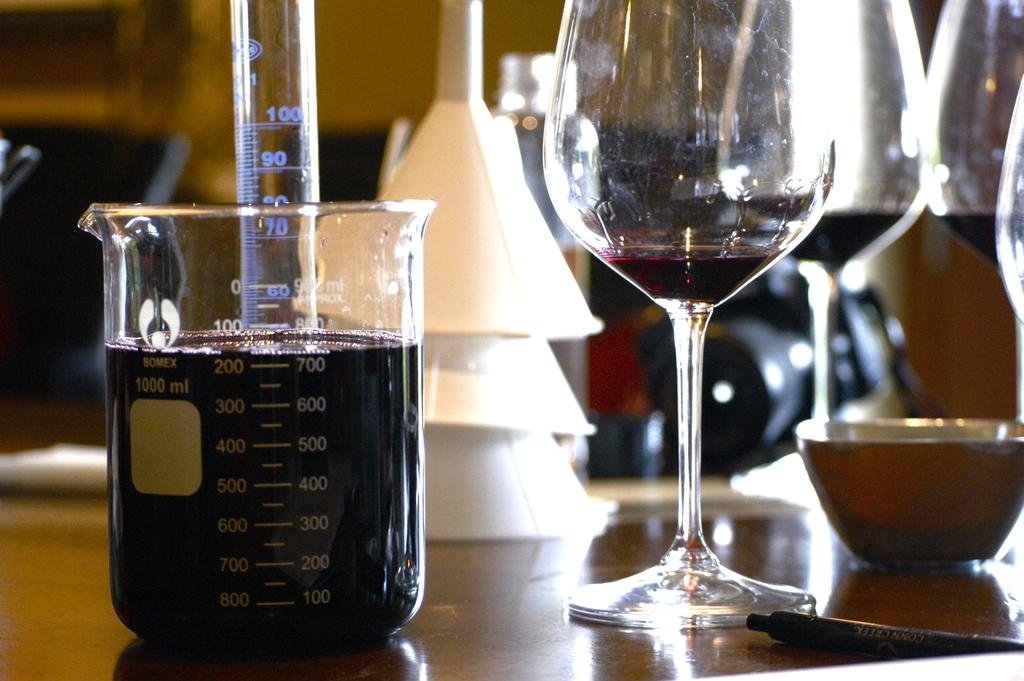<image>
Present a compact description of the photo's key features. A glass of wine next to a measuring cup with digits like 400 and 500 listed. 